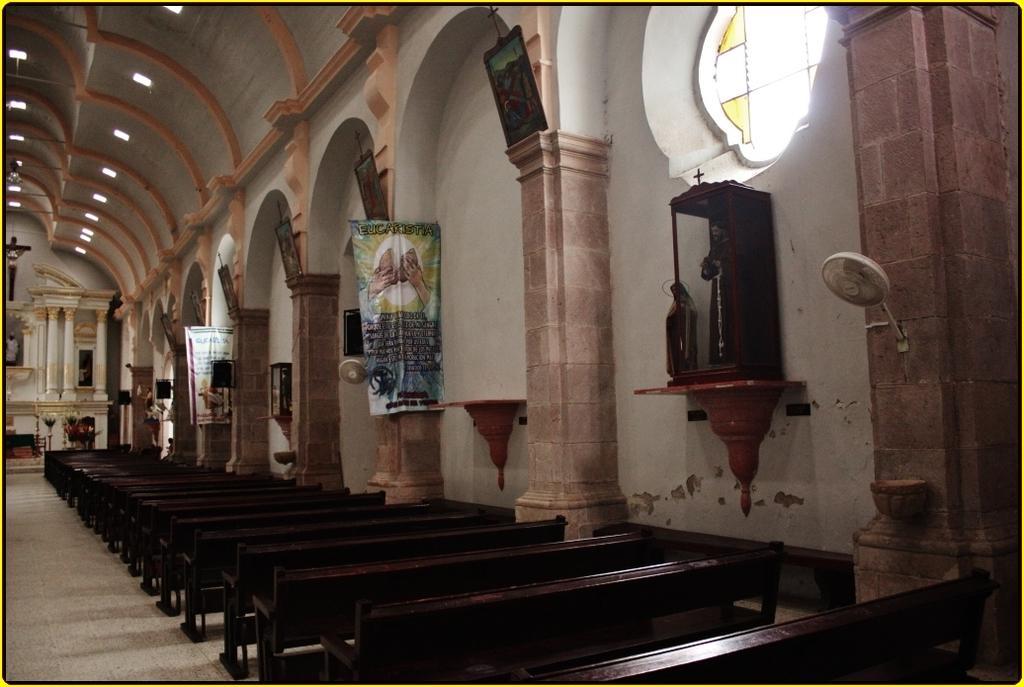In one or two sentences, can you explain what this image depicts? This is an inside view picture of the holy church. At the top we can see ceiling and lights. Far we can see the holy cross and the sculptures. On the right side we can see banners, window, frames, a sculpture and a fan on the wall. At the bottom we can see the benches and the floor. 